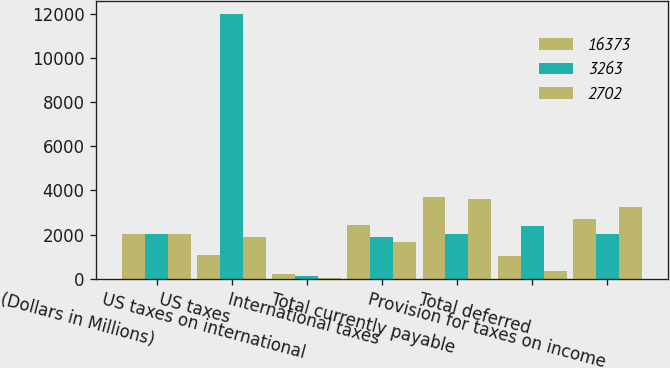Convert chart to OTSL. <chart><loc_0><loc_0><loc_500><loc_500><stacked_bar_chart><ecel><fcel>(Dollars in Millions)<fcel>US taxes<fcel>US taxes on international<fcel>International taxes<fcel>Total currently payable<fcel>Total deferred<fcel>Provision for taxes on income<nl><fcel>16373<fcel>2018<fcel>1081<fcel>203<fcel>2434<fcel>3718<fcel>1016<fcel>2702<nl><fcel>3263<fcel>2017<fcel>11969<fcel>126<fcel>1872<fcel>2016<fcel>2406<fcel>2016<nl><fcel>2702<fcel>2016<fcel>1896<fcel>49<fcel>1659<fcel>3604<fcel>341<fcel>3263<nl></chart> 